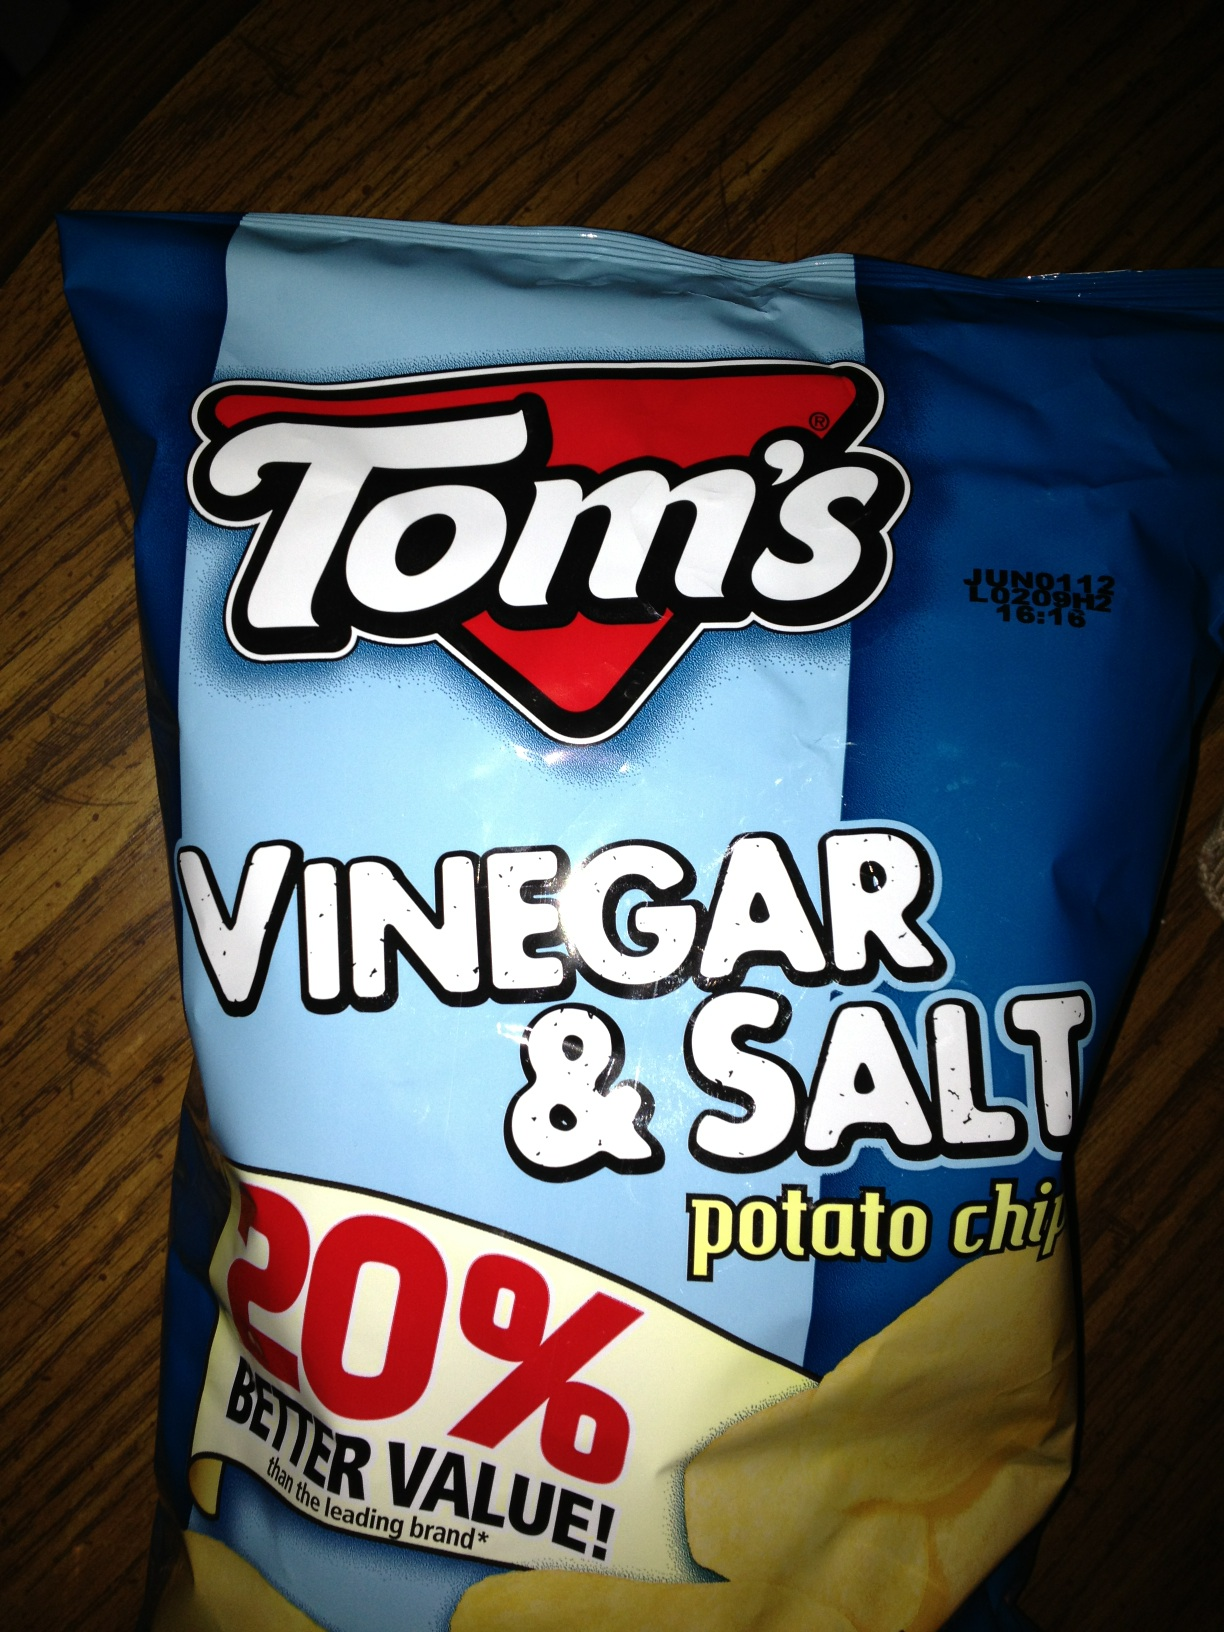Imagine these chips have a personality. What would it be like? If these chips had a personality, they would be the life of the party—bold, tangy, and always bringing a fun twist to the table. They would be spontaneous adventurers, always ready to explore new flavors and experiences with a zest for life that is as sharp as their vinegar kick and as reliable as their salty embrace. Can you create a detailed backstory or origin story for these chips? In the quaint town of Flavorville, an innovative chef named Tom embarked on a mission to create the ultimate potato chip. Drawing inspiration from ancient culinary secrets, he decided to combine the traditional tanginess of vinegar, used historically for its sharp and preserving qualities, with the beloved staple of sea salt known for enhancing flavors naturally. Tom's kitchen was filled with the scent of sizzling potatoes and the tang of vinegar. After numerous trials and a few fire alarms, Tom perfected his recipe, creating a chip that was not only deliciously tangy but also had a savory balance that left people craving more. With the promise of 20% better value, Tom’s Vinegar & Salt potato chips rapidly became the snack of choice, providing a little burst of history and flavor in every bite. The chips were now not just a snack, but a journey through time and taste, wrapped up in a crisply packaged bag.  How might these chips be featured in a gourmet dining experience? In a gourmet dining experience, Tom’s Vinegar & Salt potato chips could be transformed into an elegant amuse-bouche. Picture a delicate serving of smoked salmon perched on a bed of crushed Vinegar & Salt potato chips, topped with a dollop of crème fraîche and a sprinkling of chives. Or imagine a gastronomic twist where the chips are used to craft a sophisticated canapé: potato chip crusted goat cheese balls, drizzled with a balsharegpt4v/samic reduction, offering diners the perfect blend of crunchy texture, tangy flavor, and creamy richness. Create a short and a long realistic scenario where these chips play a key role. Short Scenario: During a casual weekend picnic, friends gather around a blanket. One friend pulls out a bag of Tom’s Vinegar & Salt potato chips, and they quickly become the star of the spread, with everyone enjoying the delightful crunch and tangy flavor between bites of sandwiches and sips of iced tea.

Long Scenario: On a sunny Saturday afternoon, a family reunion takes place in a beautiful park. Tables are set with an array of homemade dishes, but the highlight is a special food booth run by Grandma Tomlinson. Known for her culinary creativity, she unveils her latest creation: a Gourmet Vinegar & Salt Potato Chip Bar. Guests are invited to create their own culinary masterpieces using Tom's chips as the base. Some top them with artisanal cheeses and honey drizzles, others with fresh guacamole and pico de gallo, while kids have fun dunking them into strawberry-infused whipped cream. The interactive and flavorful experience becomes the talk of the reunion, bringing generations together over the shared love of a simple, yet distinctly flavorful, potato chip. 